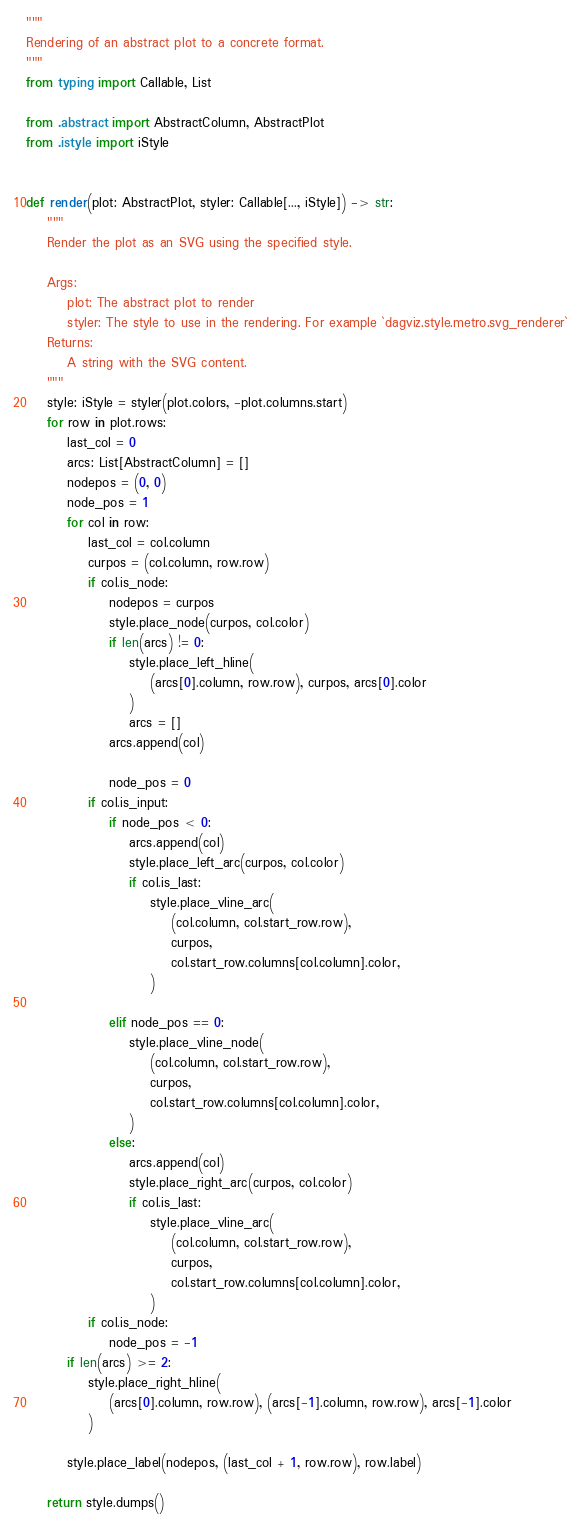<code> <loc_0><loc_0><loc_500><loc_500><_Python_>"""
Rendering of an abstract plot to a concrete format.
"""
from typing import Callable, List

from .abstract import AbstractColumn, AbstractPlot
from .istyle import iStyle


def render(plot: AbstractPlot, styler: Callable[..., iStyle]) -> str:
    """
    Render the plot as an SVG using the specified style.

    Args:
        plot: The abstract plot to render
        styler: The style to use in the rendering. For example `dagviz.style.metro.svg_renderer`
    Returns:
        A string with the SVG content.
    """
    style: iStyle = styler(plot.colors, -plot.columns.start)
    for row in plot.rows:
        last_col = 0
        arcs: List[AbstractColumn] = []
        nodepos = (0, 0)
        node_pos = 1
        for col in row:
            last_col = col.column
            curpos = (col.column, row.row)
            if col.is_node:
                nodepos = curpos
                style.place_node(curpos, col.color)
                if len(arcs) != 0:
                    style.place_left_hline(
                        (arcs[0].column, row.row), curpos, arcs[0].color
                    )
                    arcs = []
                arcs.append(col)

                node_pos = 0
            if col.is_input:
                if node_pos < 0:
                    arcs.append(col)
                    style.place_left_arc(curpos, col.color)
                    if col.is_last:
                        style.place_vline_arc(
                            (col.column, col.start_row.row),
                            curpos,
                            col.start_row.columns[col.column].color,
                        )

                elif node_pos == 0:
                    style.place_vline_node(
                        (col.column, col.start_row.row),
                        curpos,
                        col.start_row.columns[col.column].color,
                    )
                else:
                    arcs.append(col)
                    style.place_right_arc(curpos, col.color)
                    if col.is_last:
                        style.place_vline_arc(
                            (col.column, col.start_row.row),
                            curpos,
                            col.start_row.columns[col.column].color,
                        )
            if col.is_node:
                node_pos = -1
        if len(arcs) >= 2:
            style.place_right_hline(
                (arcs[0].column, row.row), (arcs[-1].column, row.row), arcs[-1].color
            )

        style.place_label(nodepos, (last_col + 1, row.row), row.label)

    return style.dumps()
</code> 